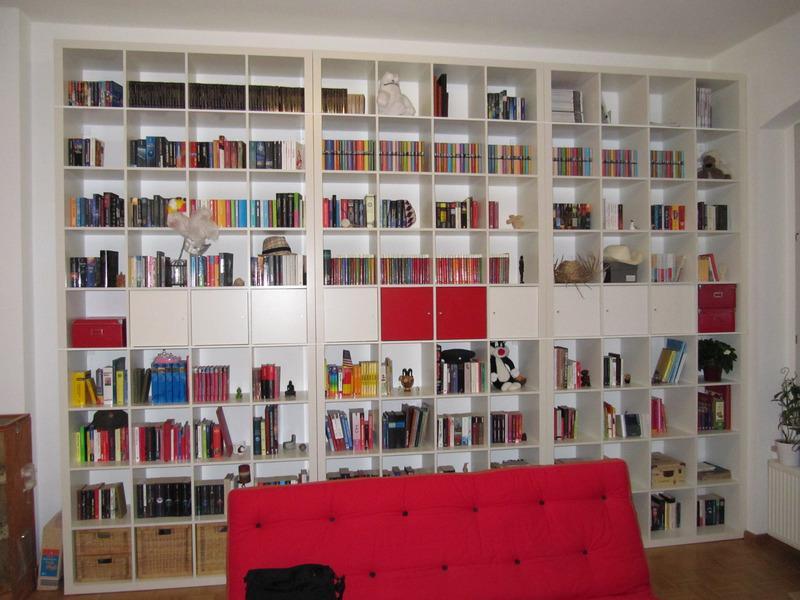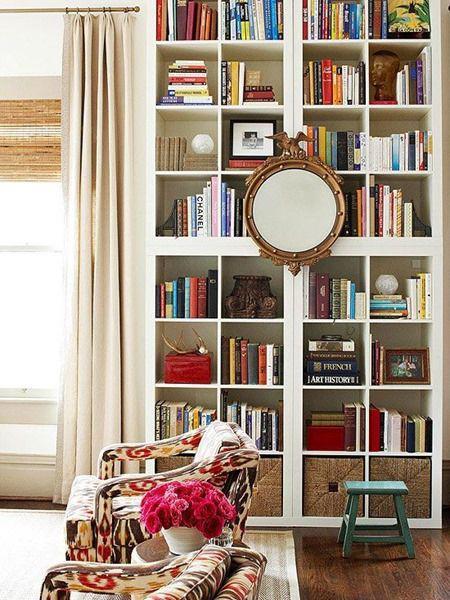The first image is the image on the left, the second image is the image on the right. Assess this claim about the two images: "there is a white bookshelf with a mirror hanging on it". Correct or not? Answer yes or no. Yes. The first image is the image on the left, the second image is the image on the right. Analyze the images presented: Is the assertion "The wall-filling white shelf unit in the left image features multiple red squares." valid? Answer yes or no. Yes. 